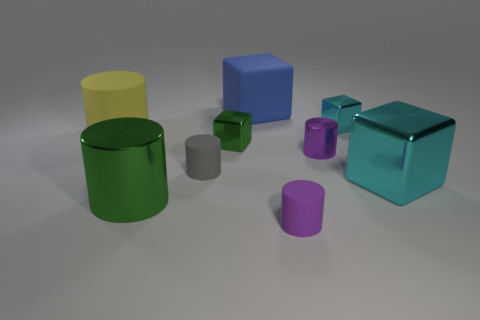Subtract all yellow cylinders. How many cylinders are left? 4 Subtract all tiny metallic cylinders. How many cylinders are left? 4 Subtract all blue cylinders. Subtract all yellow balls. How many cylinders are left? 5 Add 1 gray rubber things. How many objects exist? 10 Subtract all cylinders. How many objects are left? 4 Add 3 purple matte cylinders. How many purple matte cylinders exist? 4 Subtract 0 green spheres. How many objects are left? 9 Subtract all small green things. Subtract all small metal blocks. How many objects are left? 6 Add 2 cyan things. How many cyan things are left? 4 